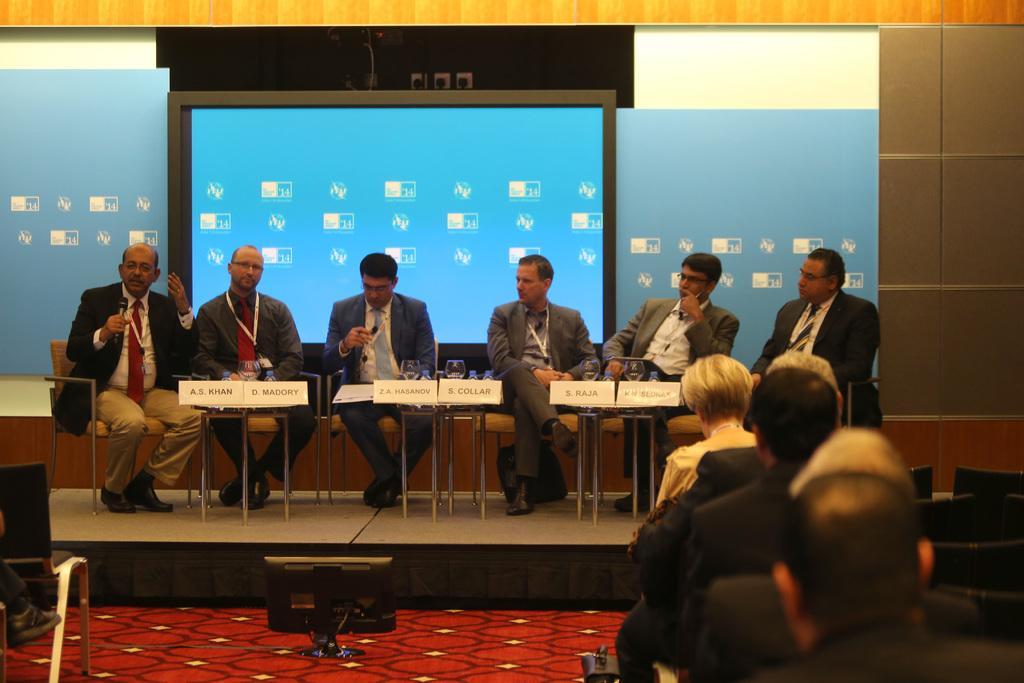Describe this image in one or two sentences. In this picture we can see six men wore blazers, ties, id cards, sitting on chairs and a man holding a mic with his hand and in front of them we can see glasses, name boards, bottles and on the floor we can see a television, some people are sitting on chairs and in the background we can see a screen, wall and some objects. 